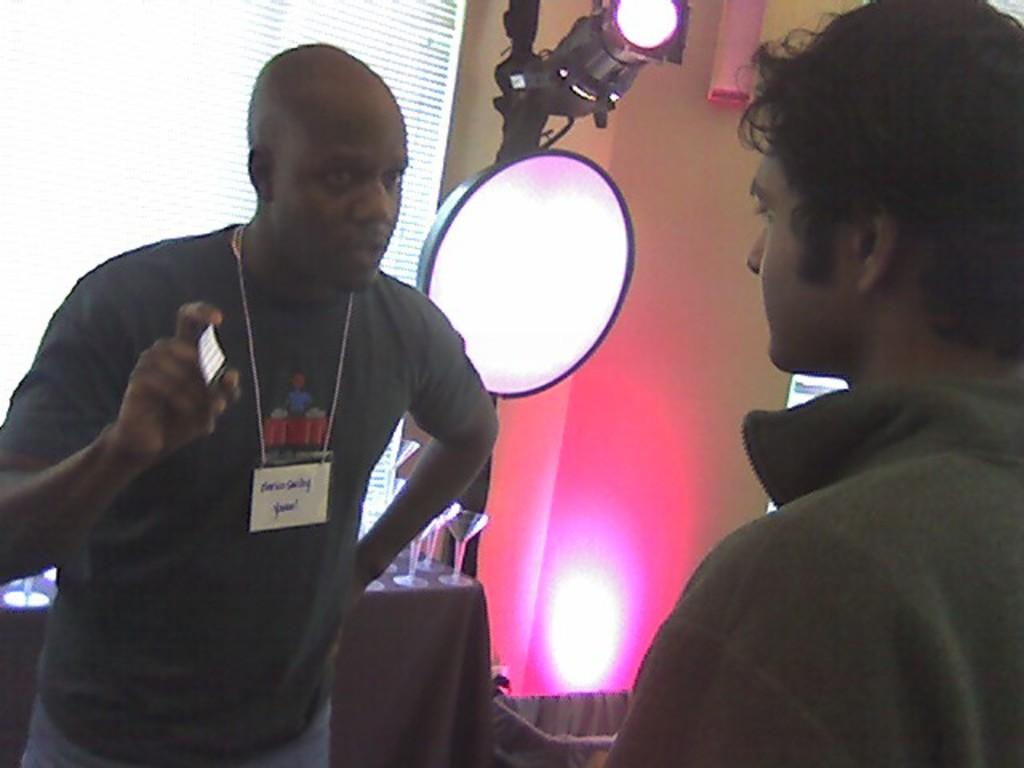How many people are in the image? There are two persons in the image. What is the person on the left doing? The person on the left is taking something. What objects can be seen on the table in the background? There are glasses on a table in the background. Can you describe the lighting in the image? There is light in the image. What is the purpose of the screen in the image? The purpose of the screen is not specified, but it is present in the image. How many trees are visible in the image? There are no trees visible in the image. Are the two persons in the image sharing a kiss? There is no indication of a kiss between the two persons in the image. 